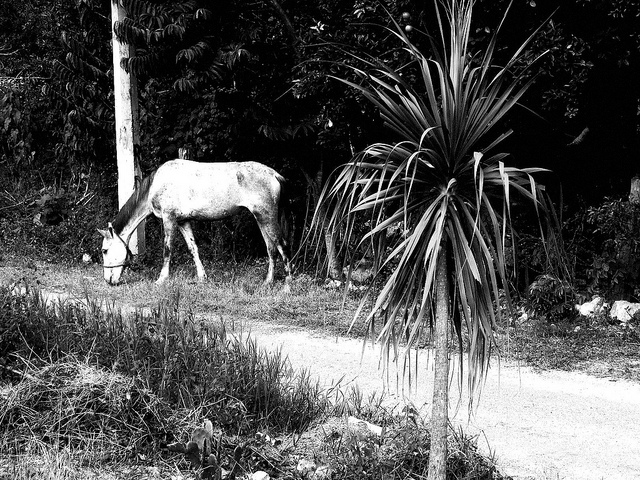Describe the surroundings in which the horse is found. The horse is in a natural setting with dense foliage that includes a variety of plants and trees. There’s also a noticeable yucca-like plant near the foreground. 